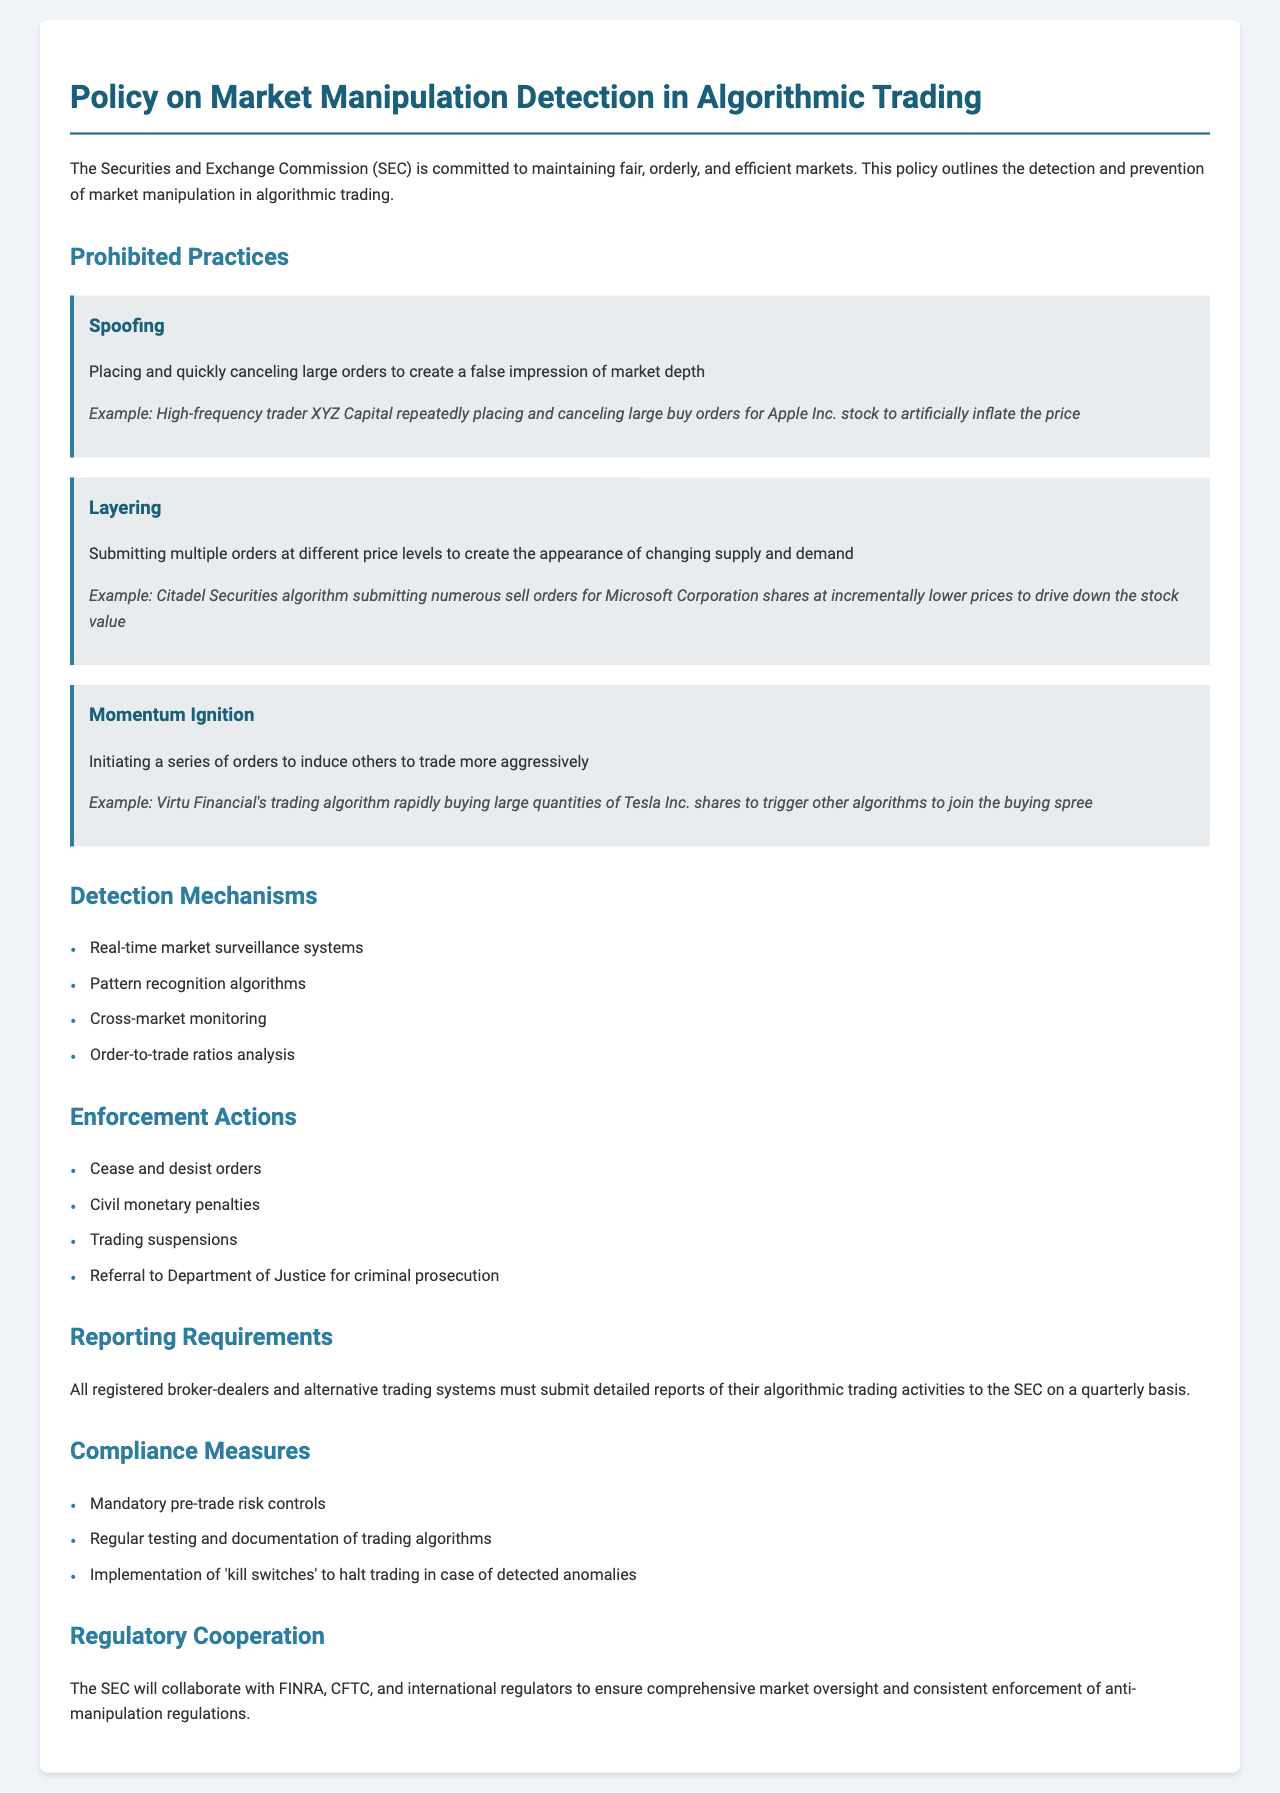What is the title of the policy document? The title of the document is presented at the top of the policy and summarizes its scope.
Answer: Policy on Market Manipulation Detection in Algorithmic Trading Who is committed to maintaining fair, orderly, and efficient markets? The introduction specifies the agency responsible for enforcing compliance in the financial markets.
Answer: Securities and Exchange Commission (SEC) What is an example of spoofing given in the document? The example provided illustrates a specific case of spoofing by a trader manipulating stock prices.
Answer: High-frequency trader XYZ Capital repeatedly placing and canceling large buy orders for Apple Inc. stock to artificially inflate the price What mechanism is used for real-time detection of market manipulation? This component of the document outlines methods for monitoring market activities to prevent manipulation.
Answer: Real-time market surveillance systems What action can be taken against entities for market manipulation? This section lists potential consequences for those found violating market rules.
Answer: Cease and desist orders What must registered broker-dealers submit to the SEC? The reporting requirements detail obligations concerning trading activities to maintain oversight.
Answer: Detailed reports of their algorithmic trading activities What practice involves submitting multiple orders at different price levels? This question focuses on a specific prohibited practice to identify deceptive trading behavior.
Answer: Layering Which organization will the SEC collaborate with for regulatory cooperation? The document mentions partnerships aimed at broader market oversight and regulatory consistency.
Answer: FINRA, CFTC, and international regulators 